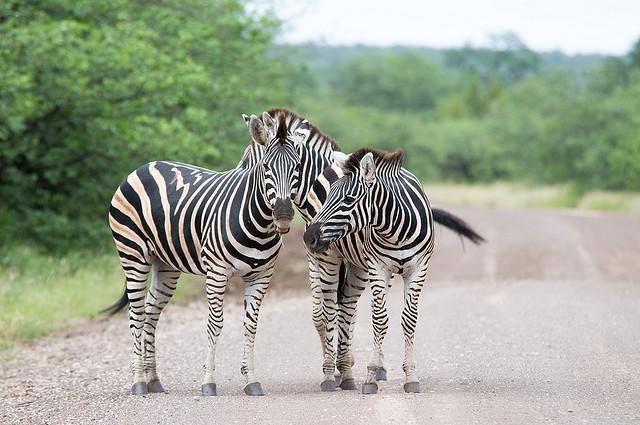How many striped animals are pictured?
Give a very brief answer. 3. How many zebras are there?
Give a very brief answer. 2. How many people are standing?
Give a very brief answer. 0. 